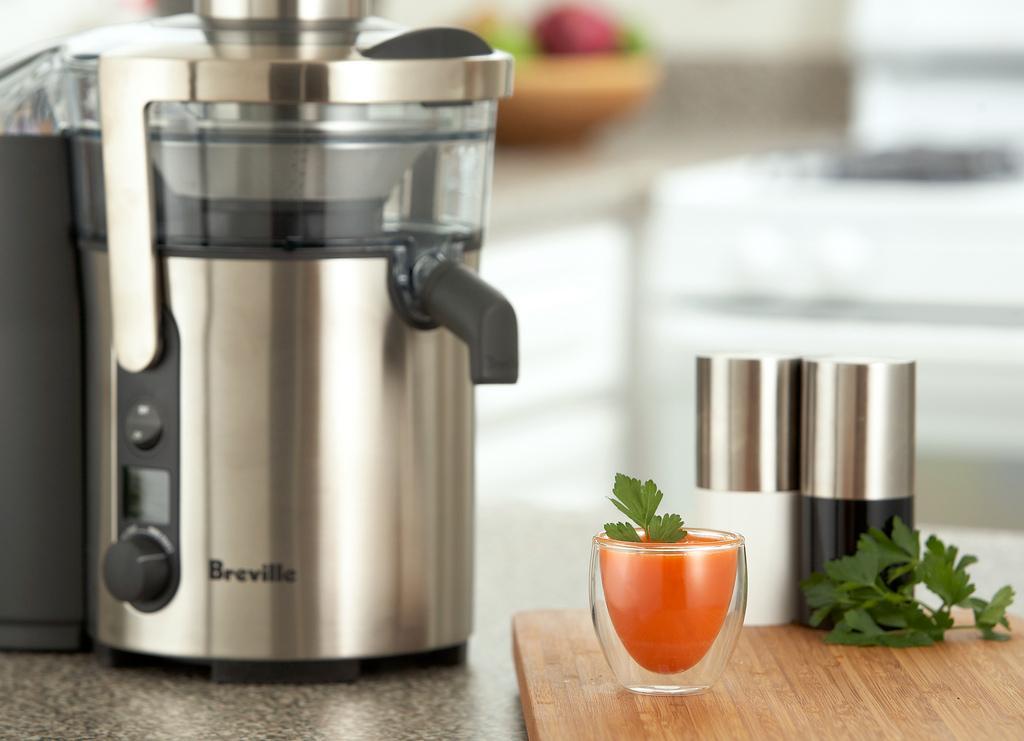Could you give a brief overview of what you see in this image? In this image we can see an object which looks like a juicer and there is some text on it and to the side, we can see a cup with drink and there is a wooden plank and leaves and we can see some other objects. In the background the image is blurred. 